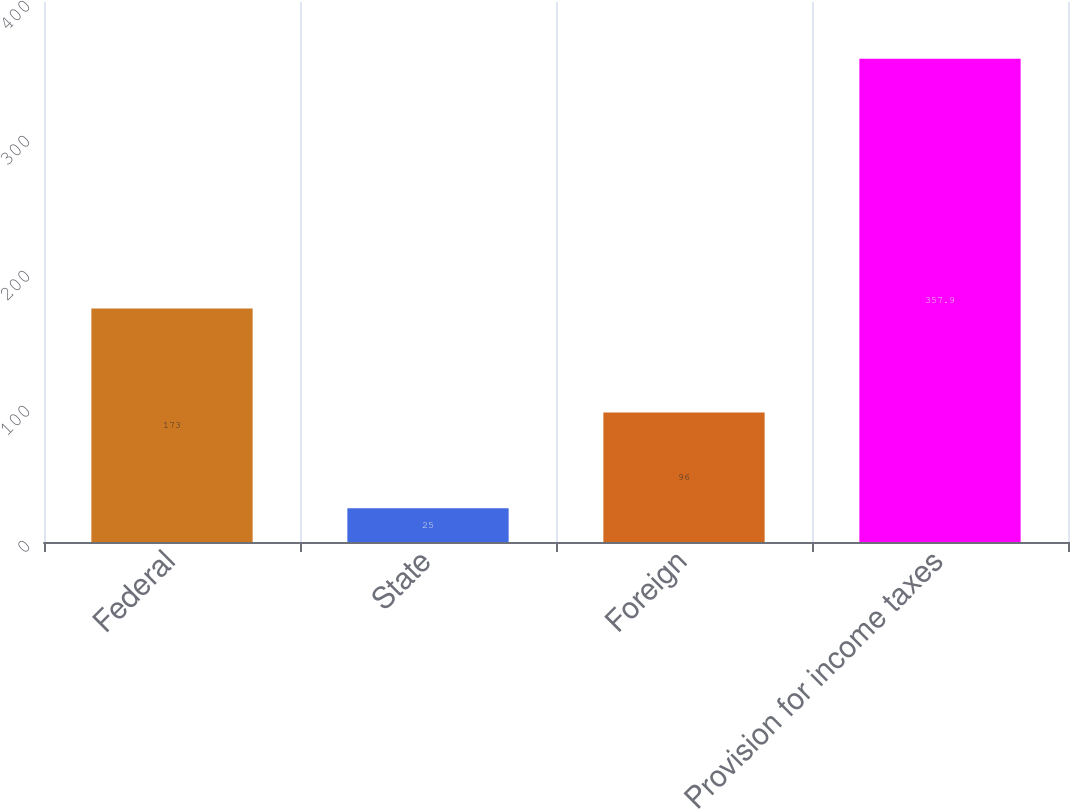<chart> <loc_0><loc_0><loc_500><loc_500><bar_chart><fcel>Federal<fcel>State<fcel>Foreign<fcel>Provision for income taxes<nl><fcel>173<fcel>25<fcel>96<fcel>357.9<nl></chart> 